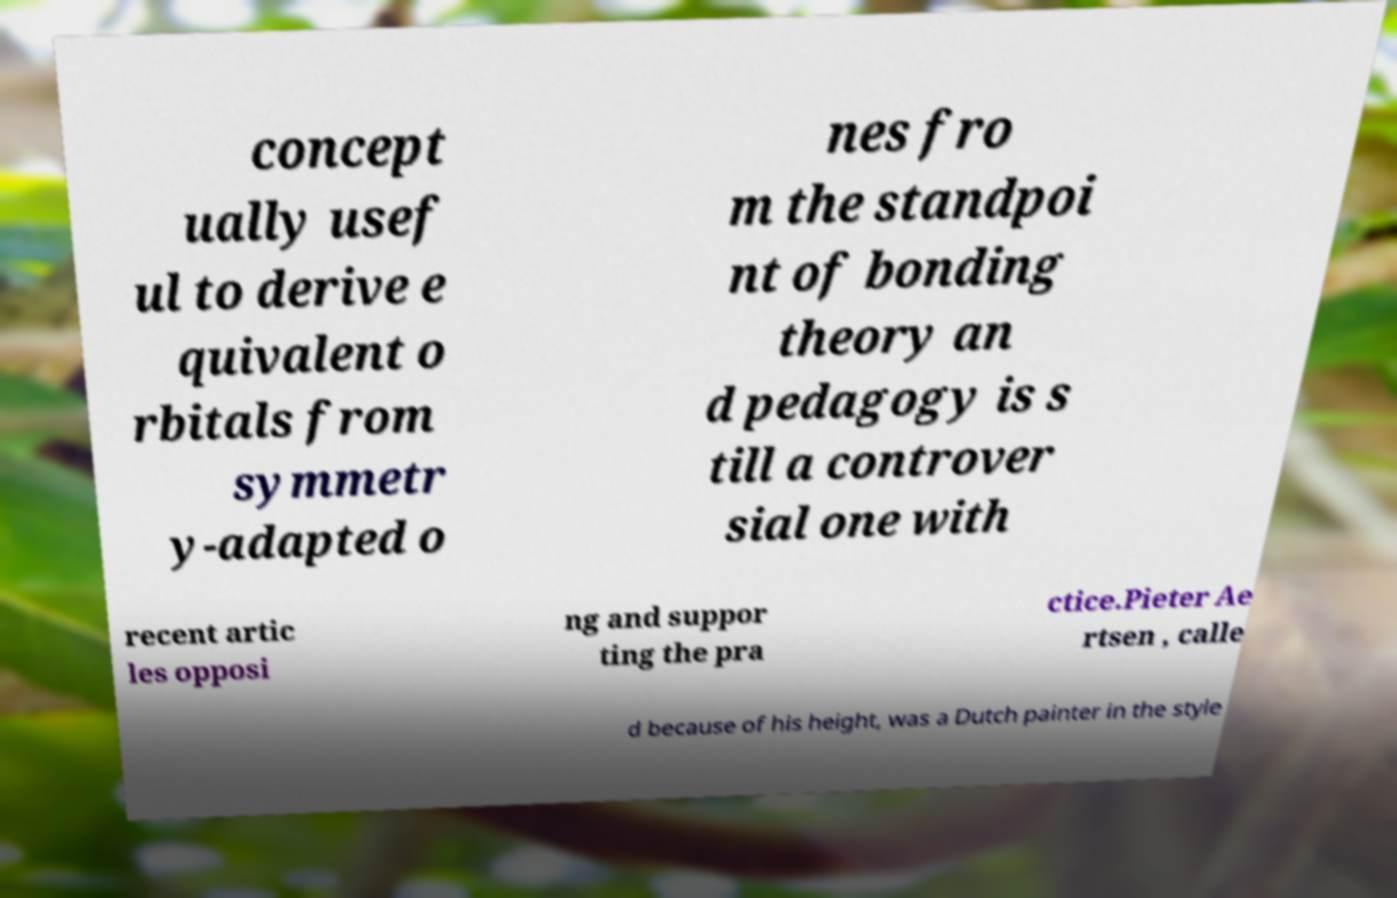Can you read and provide the text displayed in the image?This photo seems to have some interesting text. Can you extract and type it out for me? concept ually usef ul to derive e quivalent o rbitals from symmetr y-adapted o nes fro m the standpoi nt of bonding theory an d pedagogy is s till a controver sial one with recent artic les opposi ng and suppor ting the pra ctice.Pieter Ae rtsen , calle d because of his height, was a Dutch painter in the style 